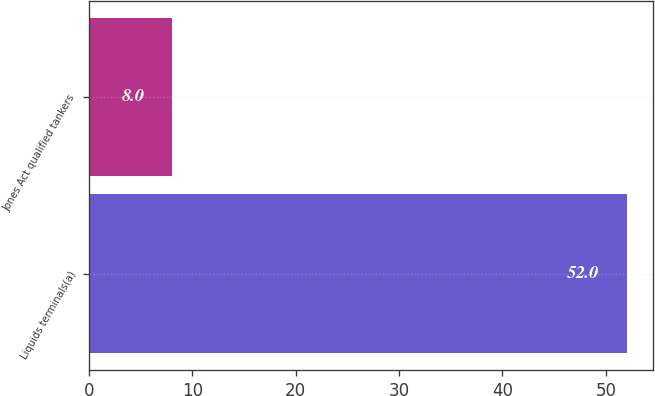Convert chart. <chart><loc_0><loc_0><loc_500><loc_500><bar_chart><fcel>Liquids terminals(a)<fcel>Jones Act qualified tankers<nl><fcel>52<fcel>8<nl></chart> 